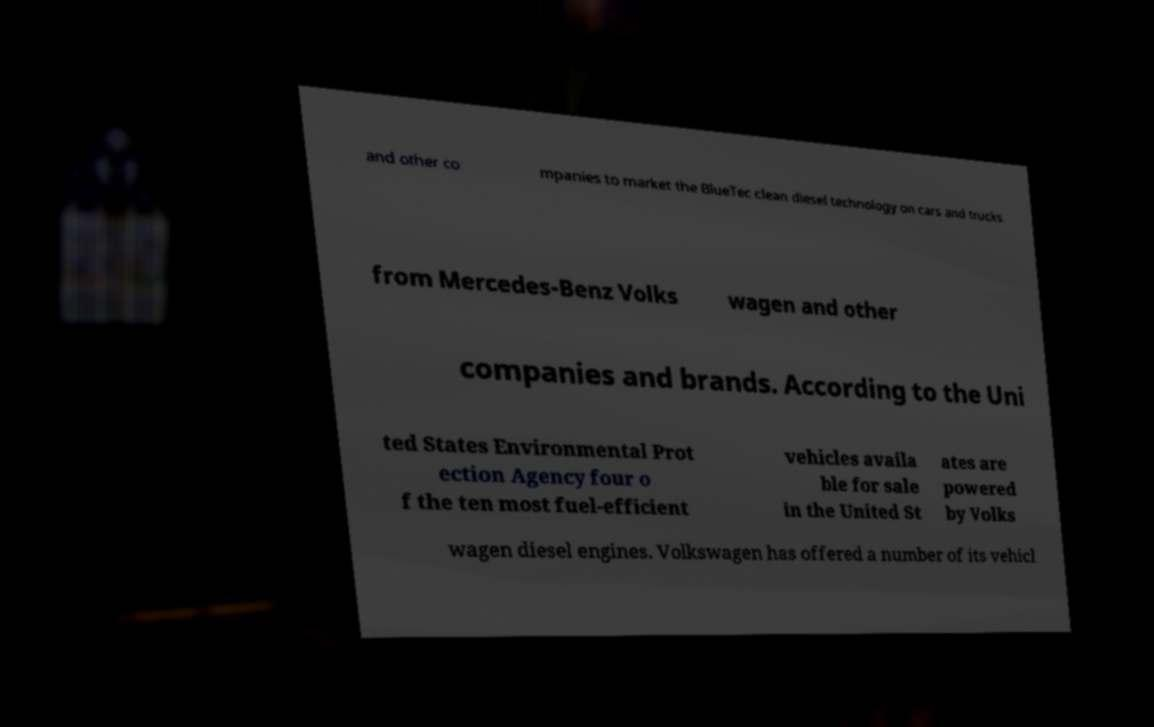Please identify and transcribe the text found in this image. and other co mpanies to market the BlueTec clean diesel technology on cars and trucks from Mercedes-Benz Volks wagen and other companies and brands. According to the Uni ted States Environmental Prot ection Agency four o f the ten most fuel-efficient vehicles availa ble for sale in the United St ates are powered by Volks wagen diesel engines. Volkswagen has offered a number of its vehicl 